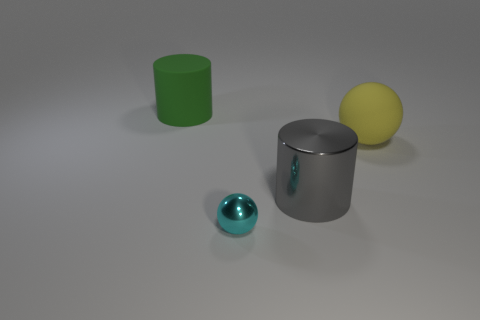Subtract all green balls. Subtract all cyan cubes. How many balls are left? 2 Add 1 small gray matte spheres. How many objects exist? 5 Add 3 green cylinders. How many green cylinders are left? 4 Add 2 large gray things. How many large gray things exist? 3 Subtract 1 cyan balls. How many objects are left? 3 Subtract all large brown spheres. Subtract all tiny cyan balls. How many objects are left? 3 